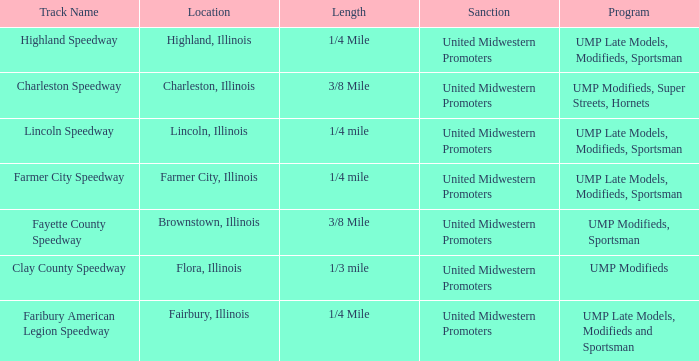What programs were held in charleston, illinois? UMP Modifieds, Super Streets, Hornets. Could you parse the entire table? {'header': ['Track Name', 'Location', 'Length', 'Sanction', 'Program'], 'rows': [['Highland Speedway', 'Highland, Illinois', '1/4 Mile', 'United Midwestern Promoters', 'UMP Late Models, Modifieds, Sportsman'], ['Charleston Speedway', 'Charleston, Illinois', '3/8 Mile', 'United Midwestern Promoters', 'UMP Modifieds, Super Streets, Hornets'], ['Lincoln Speedway', 'Lincoln, Illinois', '1/4 mile', 'United Midwestern Promoters', 'UMP Late Models, Modifieds, Sportsman'], ['Farmer City Speedway', 'Farmer City, Illinois', '1/4 mile', 'United Midwestern Promoters', 'UMP Late Models, Modifieds, Sportsman'], ['Fayette County Speedway', 'Brownstown, Illinois', '3/8 Mile', 'United Midwestern Promoters', 'UMP Modifieds, Sportsman'], ['Clay County Speedway', 'Flora, Illinois', '1/3 mile', 'United Midwestern Promoters', 'UMP Modifieds'], ['Faribury American Legion Speedway', 'Fairbury, Illinois', '1/4 Mile', 'United Midwestern Promoters', 'UMP Late Models, Modifieds and Sportsman']]} 